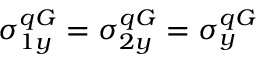Convert formula to latex. <formula><loc_0><loc_0><loc_500><loc_500>\sigma _ { 1 y } ^ { q G } = \sigma _ { 2 y } ^ { q G } = \sigma _ { y } ^ { q G }</formula> 